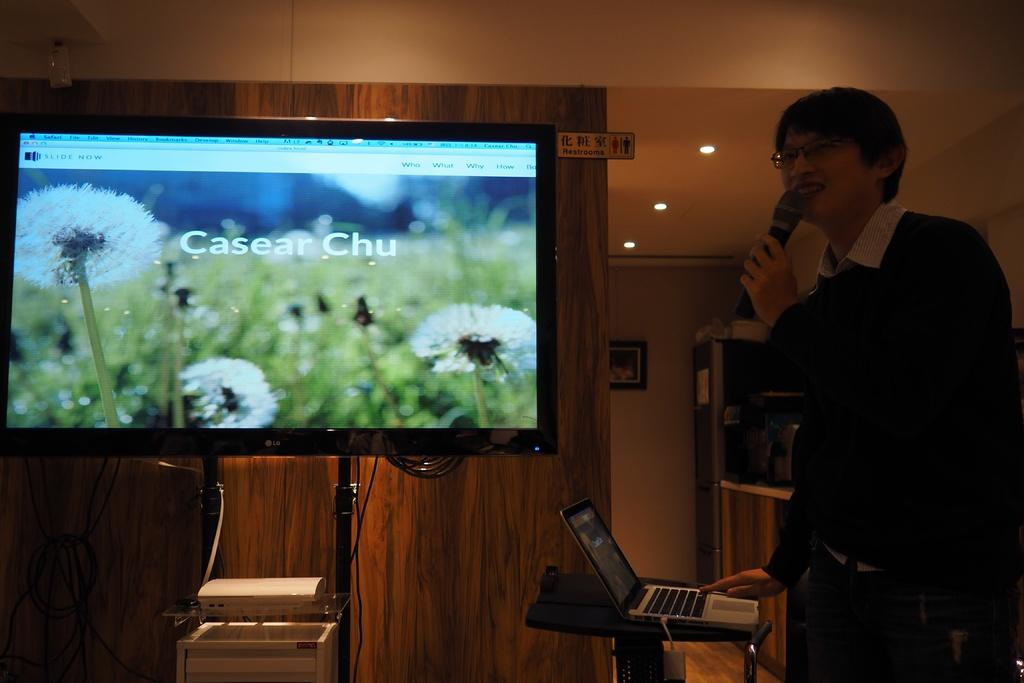<image>
Relay a brief, clear account of the picture shown. A man with a microphone showing a slide that says Casear Chu 